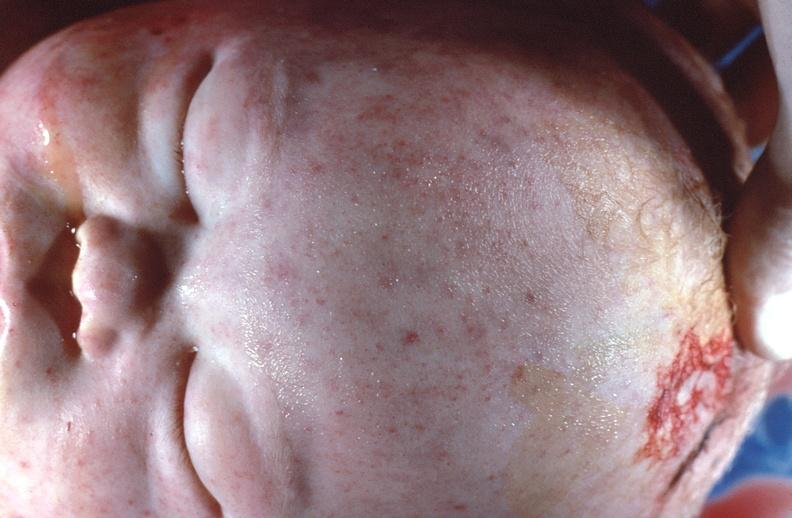does acid show gram negative septicemia due to scalp electrode in a neonate?
Answer the question using a single word or phrase. No 